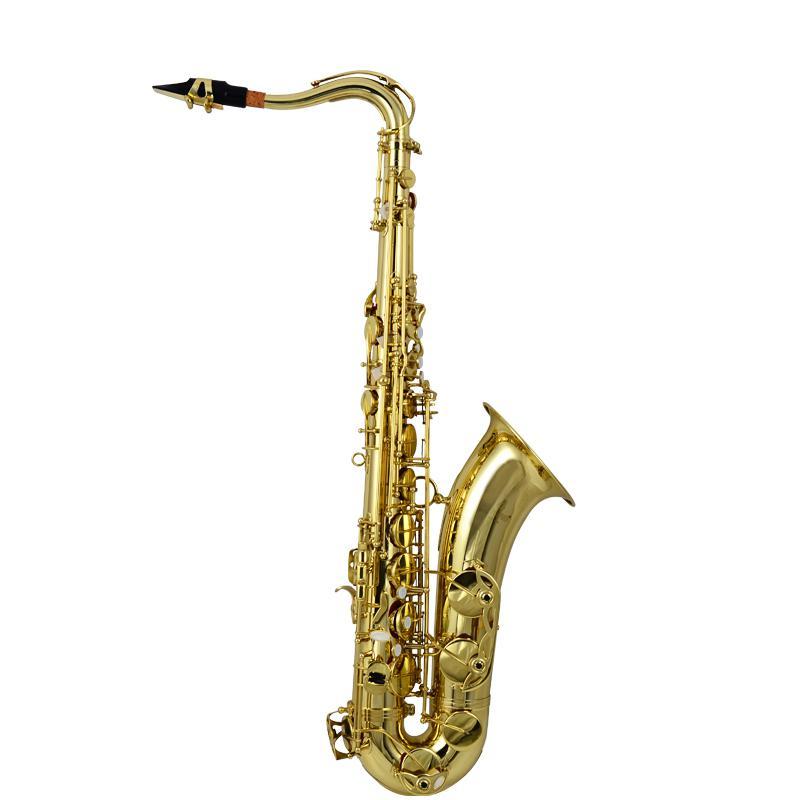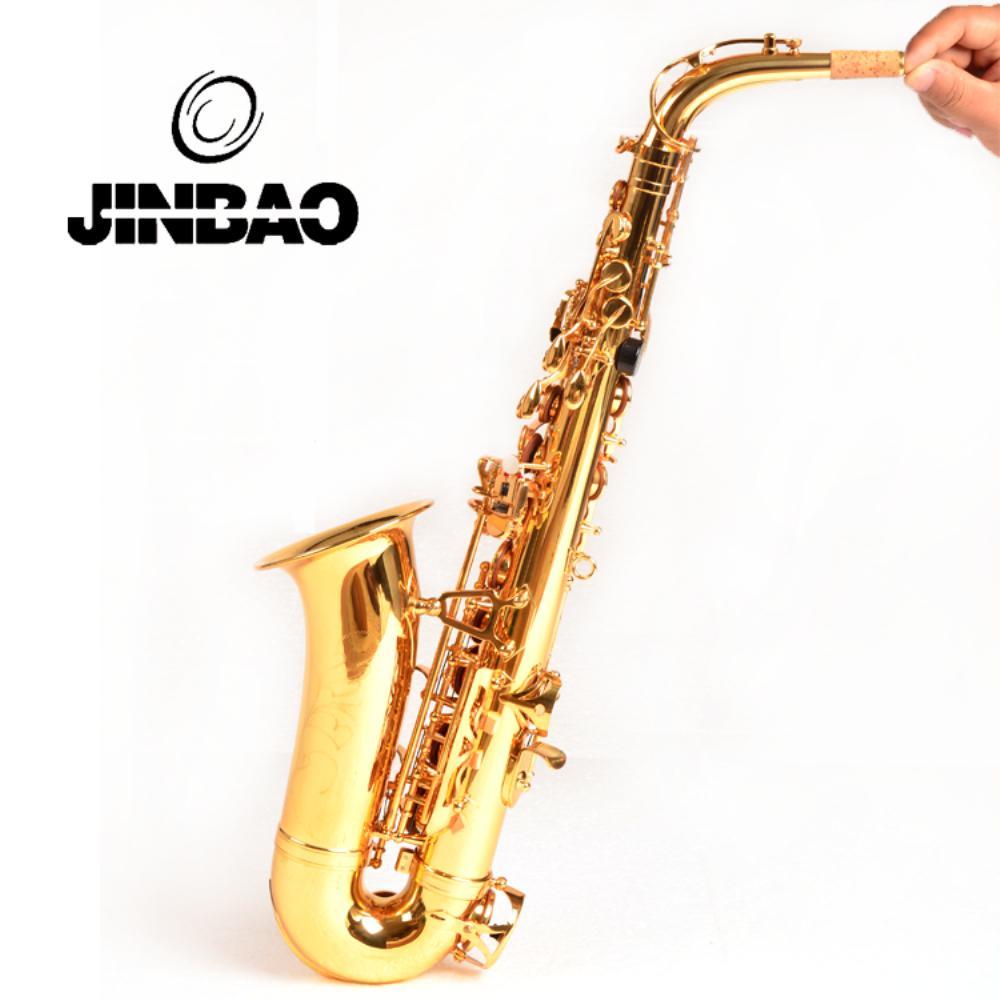The first image is the image on the left, the second image is the image on the right. For the images shown, is this caption "An image shows a right-facing saxophone displayed vertically." true? Answer yes or no. Yes. The first image is the image on the left, the second image is the image on the right. For the images displayed, is the sentence "The entire saxophone is visible in each image." factually correct? Answer yes or no. Yes. 